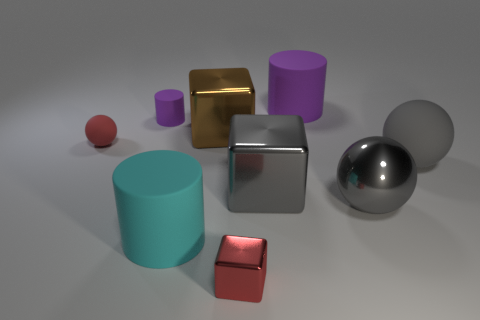How many small objects are to the right of the small red object on the left side of the red block?
Your response must be concise. 2. Is there a blue sphere?
Ensure brevity in your answer.  No. How many other things are the same color as the tiny ball?
Offer a terse response. 1. Are there fewer red rubber spheres than large yellow blocks?
Provide a succinct answer. No. There is a purple matte thing that is right of the block behind the tiny red rubber sphere; what is its shape?
Provide a succinct answer. Cylinder. There is a large purple matte cylinder; are there any large rubber cylinders left of it?
Ensure brevity in your answer.  Yes. The shiny object that is the same size as the red matte ball is what color?
Keep it short and to the point. Red. What number of gray cubes have the same material as the big cyan cylinder?
Your answer should be compact. 0. How many other things are the same size as the brown metallic object?
Provide a short and direct response. 5. Is there a green metallic ball that has the same size as the cyan rubber cylinder?
Provide a short and direct response. No. 